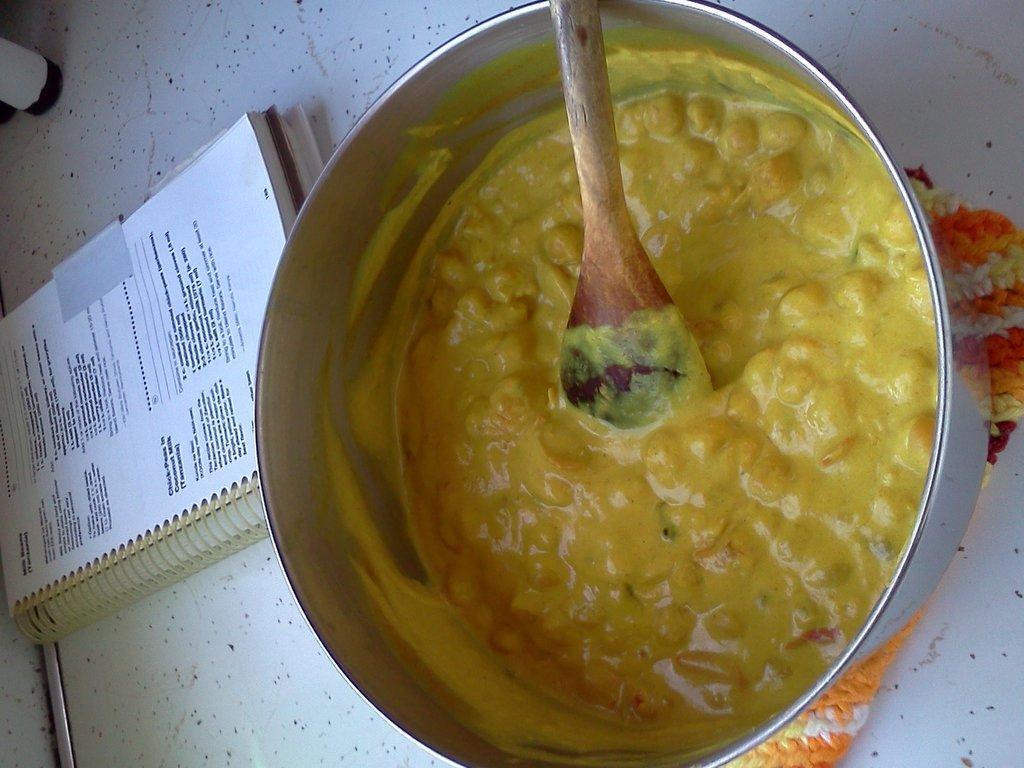Please provide a concise description of this image. In this image I can see food item and wooden spoon in a steel bowl. Here I can see a book. These objects are on a white color surface. 